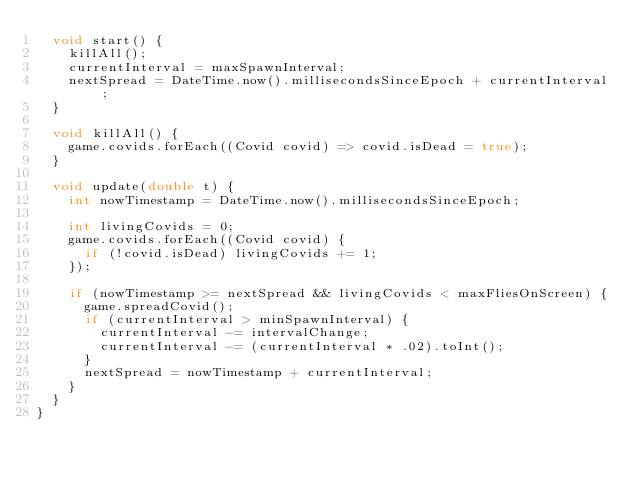Convert code to text. <code><loc_0><loc_0><loc_500><loc_500><_Dart_>  void start() {
    killAll();
    currentInterval = maxSpawnInterval;
    nextSpread = DateTime.now().millisecondsSinceEpoch + currentInterval;
  }

  void killAll() {
    game.covids.forEach((Covid covid) => covid.isDead = true);
  }

  void update(double t) {
    int nowTimestamp = DateTime.now().millisecondsSinceEpoch;

    int livingCovids = 0;
    game.covids.forEach((Covid covid) {
      if (!covid.isDead) livingCovids += 1;
    });

    if (nowTimestamp >= nextSpread && livingCovids < maxFliesOnScreen) {
      game.spreadCovid();
      if (currentInterval > minSpawnInterval) {
        currentInterval -= intervalChange;
        currentInterval -= (currentInterval * .02).toInt();
      }
      nextSpread = nowTimestamp + currentInterval;
    }
  }
}
</code> 